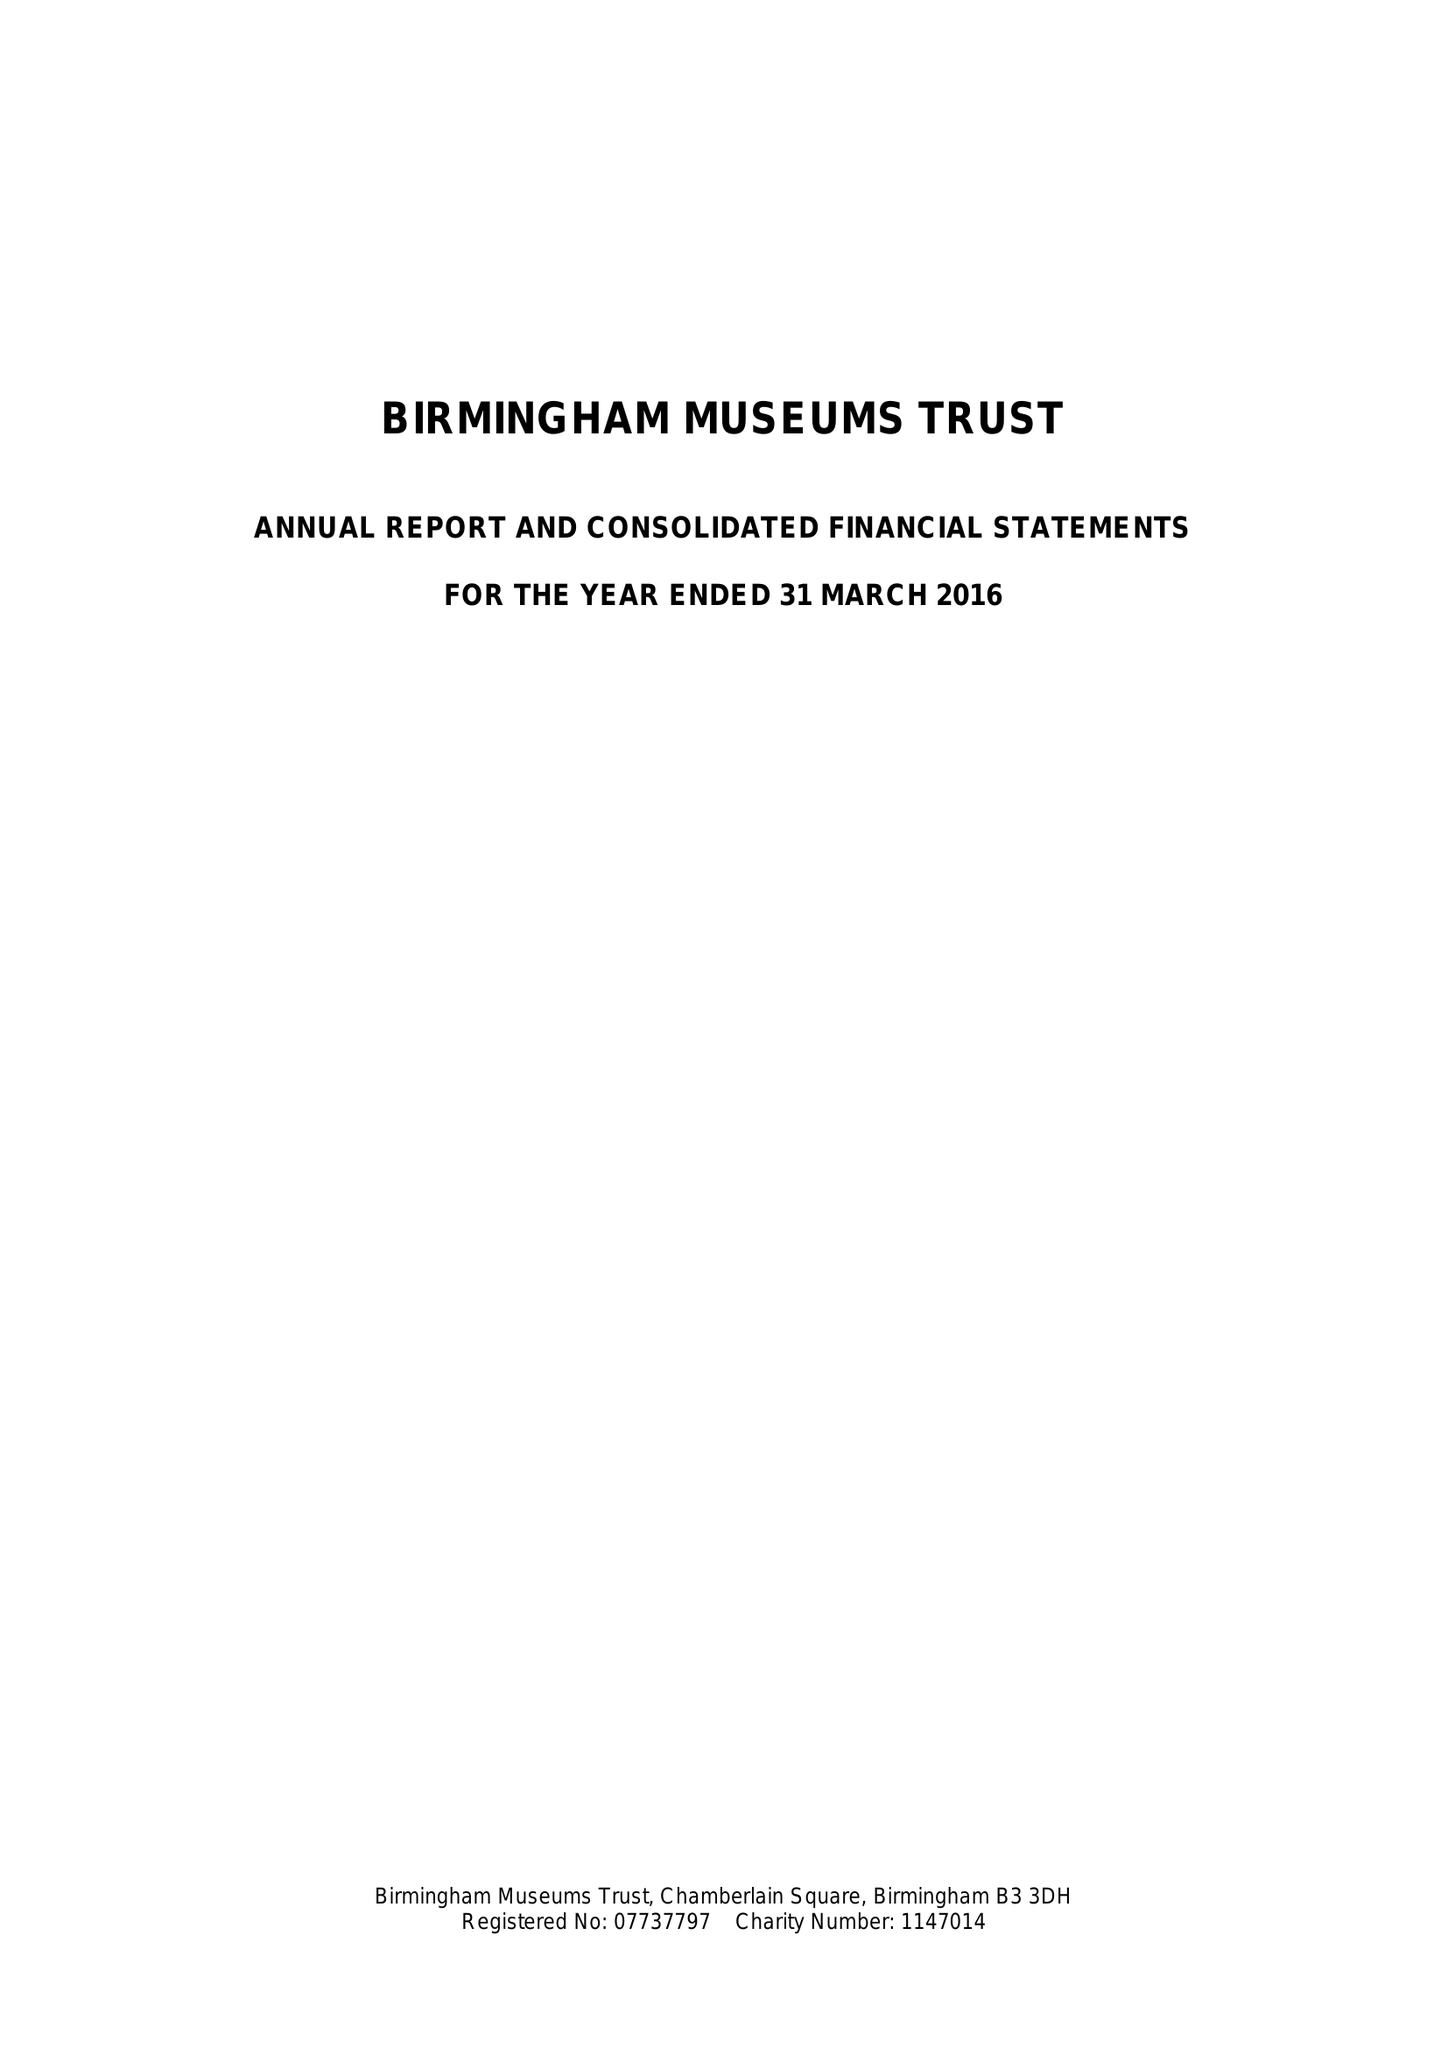What is the value for the spending_annually_in_british_pounds?
Answer the question using a single word or phrase. 11911000.00 